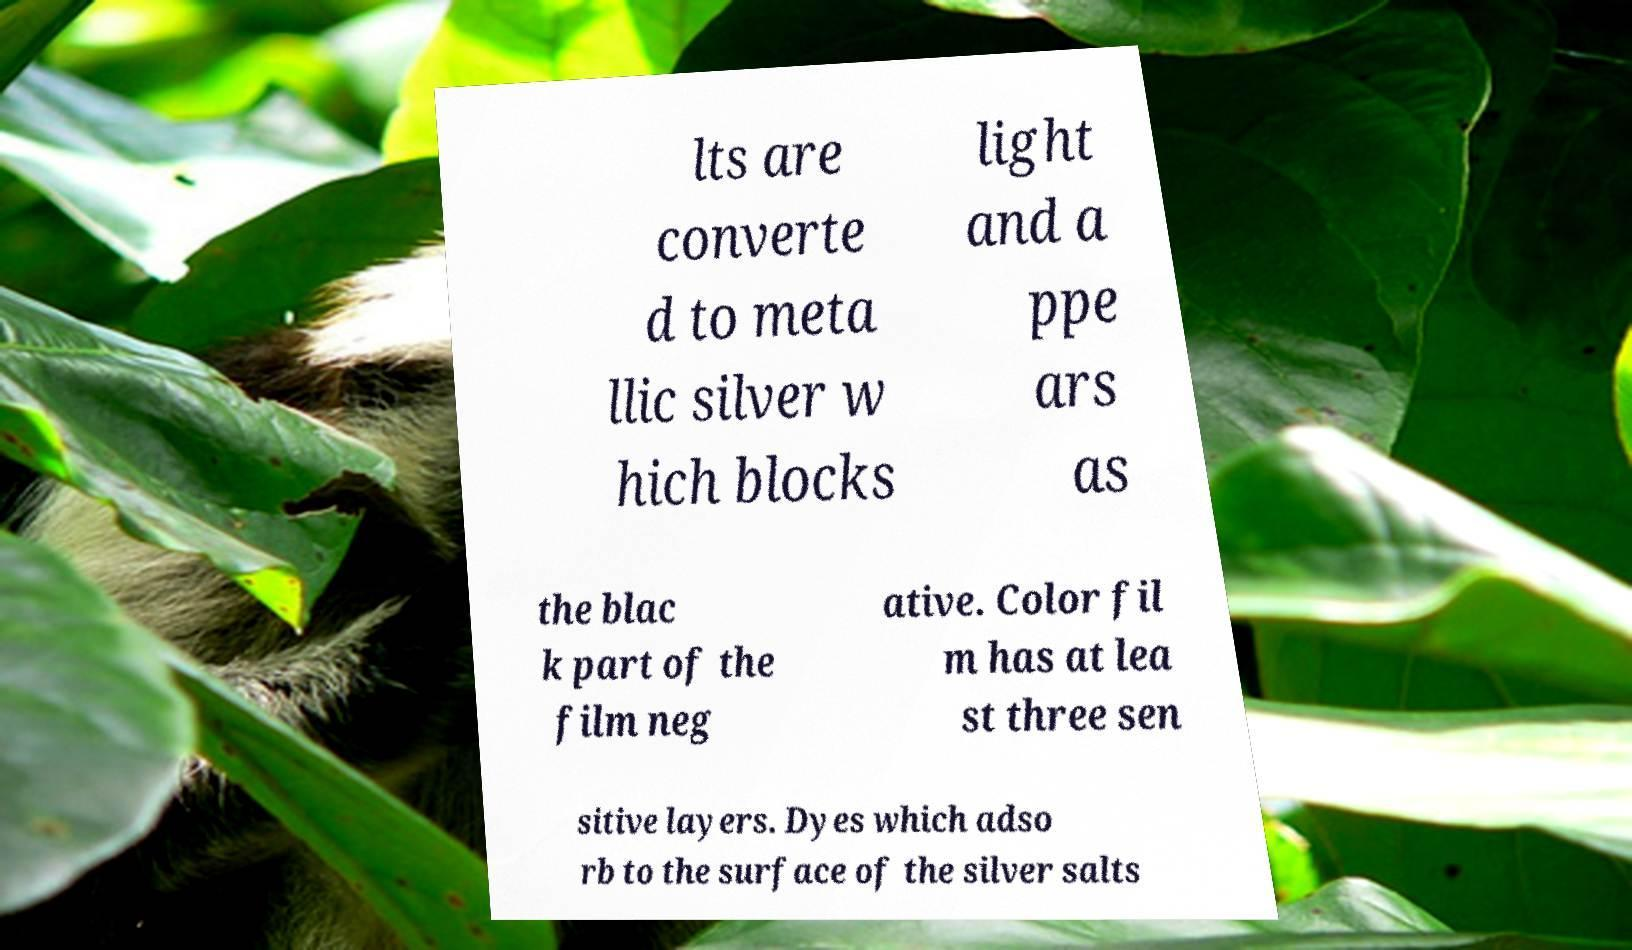There's text embedded in this image that I need extracted. Can you transcribe it verbatim? lts are converte d to meta llic silver w hich blocks light and a ppe ars as the blac k part of the film neg ative. Color fil m has at lea st three sen sitive layers. Dyes which adso rb to the surface of the silver salts 